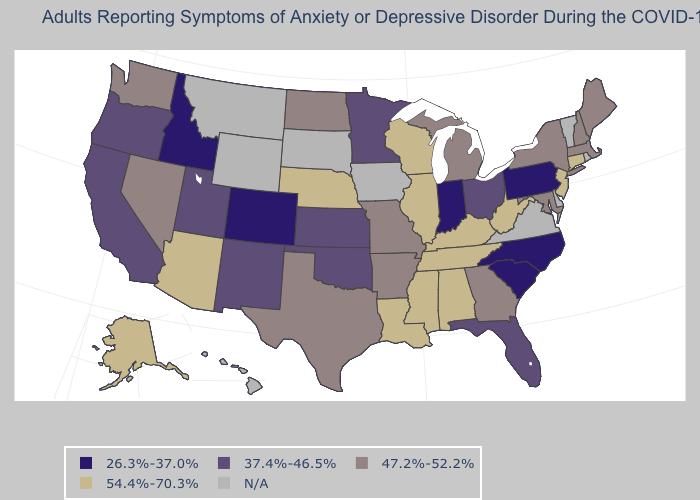Name the states that have a value in the range 26.3%-37.0%?
Write a very short answer. Colorado, Idaho, Indiana, North Carolina, Pennsylvania, South Carolina. Name the states that have a value in the range 26.3%-37.0%?
Answer briefly. Colorado, Idaho, Indiana, North Carolina, Pennsylvania, South Carolina. Name the states that have a value in the range 26.3%-37.0%?
Quick response, please. Colorado, Idaho, Indiana, North Carolina, Pennsylvania, South Carolina. What is the highest value in the Northeast ?
Short answer required. 54.4%-70.3%. Name the states that have a value in the range N/A?
Give a very brief answer. Delaware, Hawaii, Iowa, Montana, Rhode Island, South Dakota, Vermont, Virginia, Wyoming. What is the lowest value in the MidWest?
Be succinct. 26.3%-37.0%. What is the lowest value in the USA?
Quick response, please. 26.3%-37.0%. Name the states that have a value in the range N/A?
Short answer required. Delaware, Hawaii, Iowa, Montana, Rhode Island, South Dakota, Vermont, Virginia, Wyoming. What is the value of Wyoming?
Write a very short answer. N/A. What is the value of Minnesota?
Write a very short answer. 37.4%-46.5%. Among the states that border Arkansas , which have the lowest value?
Short answer required. Oklahoma. 